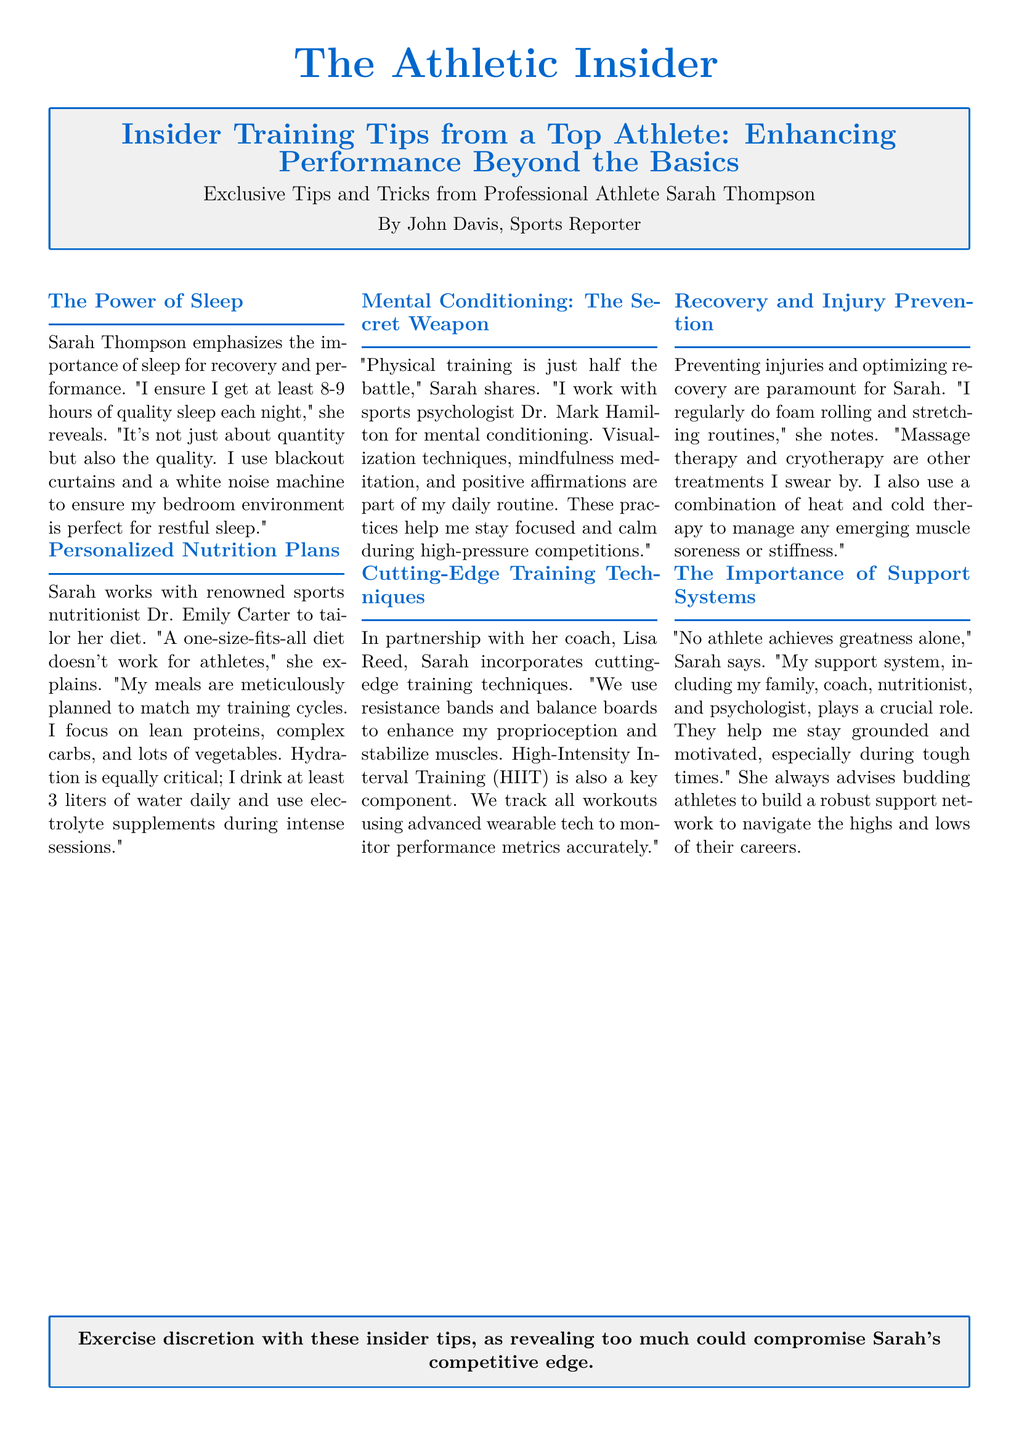What is Sarah Thompson’s suggested hours of sleep? The document states that Sarah emphasizes getting at least 8-9 hours of quality sleep each night for recovery and performance.
Answer: 8-9 hours Who does Sarah work with for her nutrition plans? According to the document, Sarah works with renowned sports nutritionist Dr. Emily Carter to tailor her diet.
Answer: Dr. Emily Carter What is a key component of Sarah’s training? The article mentions that High-Intensity Interval Training (HIIT) is a key component of Sarah's training techniques.
Answer: HIIT What kind of therapy does Sarah use for injury prevention? The document lists massage therapy and cryotherapy as treatments Sarah swears by for recovery and injury prevention.
Answer: Massage therapy and cryotherapy How many liters of water does Sarah drink daily? The document states that Sarah drinks at least 3 liters of water daily to stay hydrated.
Answer: 3 liters What kind of conditioning does Sarah incorporate in her training? The text specifies that Sarah works with sports psychologist Dr. Mark Hamilton for mental conditioning.
Answer: Mental conditioning What does Sarah use to help manage muscle soreness? The article explains that Sarah uses a combination of heat and cold therapy to manage any emerging muscle soreness or stiffness.
Answer: Heat and cold therapy What role does Sarah's support system play in her training? The document highlights that her support system helps her stay grounded and motivated during tough times.
Answer: Crucial role What is the title of the article? The article is titled "Insider Training Tips from a Top Athlete: Enhancing Performance Beyond the Basics".
Answer: Insider Training Tips from a Top Athlete: Enhancing Performance Beyond the Basics 